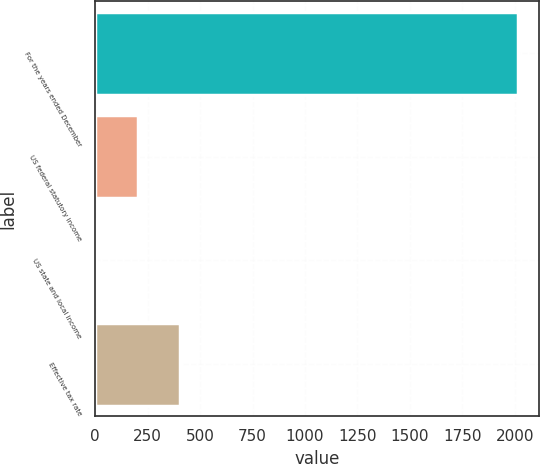Convert chart to OTSL. <chart><loc_0><loc_0><loc_500><loc_500><bar_chart><fcel>For the years ended December<fcel>US federal statutory income<fcel>US state and local income<fcel>Effective tax rate<nl><fcel>2016<fcel>203.58<fcel>2.2<fcel>404.96<nl></chart> 